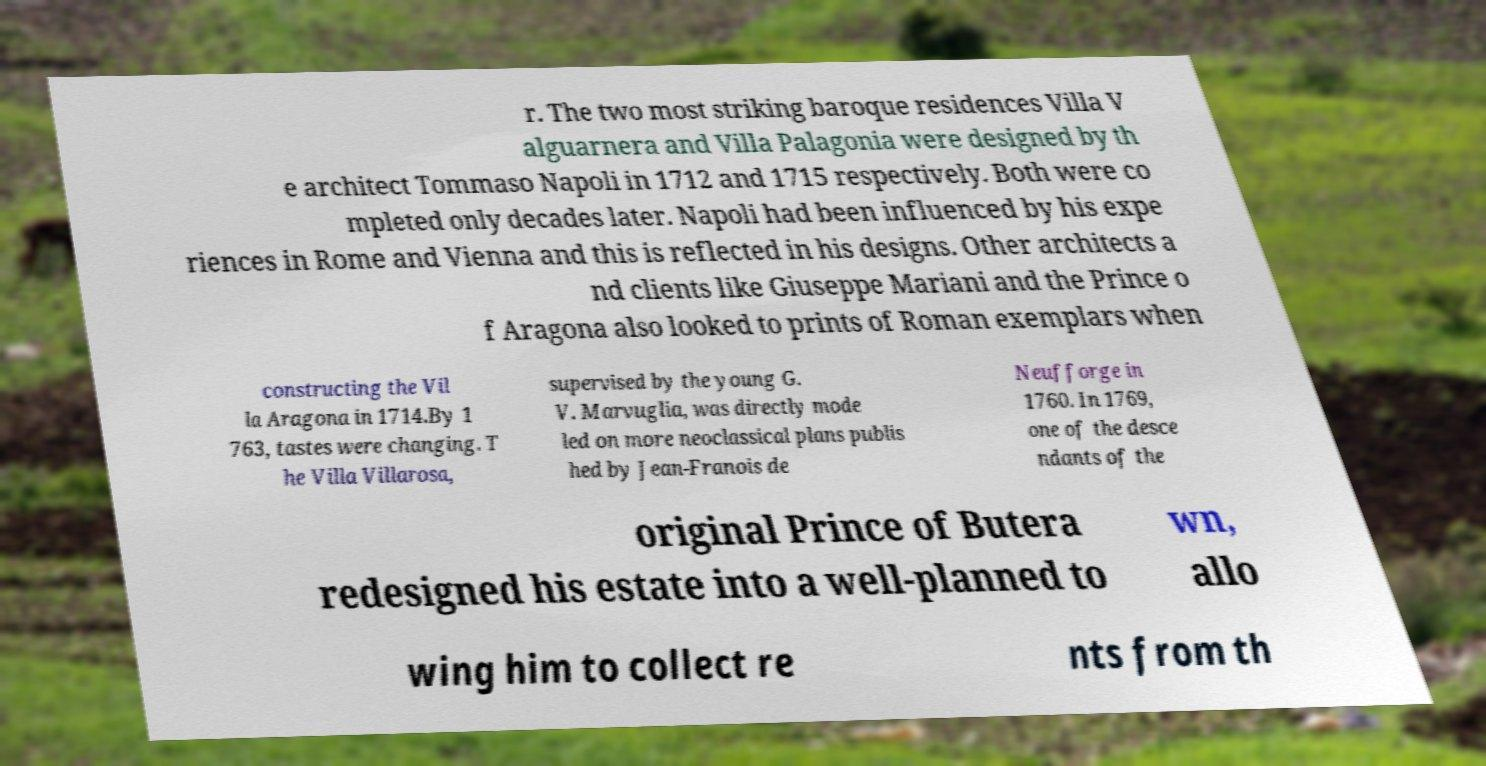For documentation purposes, I need the text within this image transcribed. Could you provide that? r. The two most striking baroque residences Villa V alguarnera and Villa Palagonia were designed by th e architect Tommaso Napoli in 1712 and 1715 respectively. Both were co mpleted only decades later. Napoli had been influenced by his expe riences in Rome and Vienna and this is reflected in his designs. Other architects a nd clients like Giuseppe Mariani and the Prince o f Aragona also looked to prints of Roman exemplars when constructing the Vil la Aragona in 1714.By 1 763, tastes were changing. T he Villa Villarosa, supervised by the young G. V. Marvuglia, was directly mode led on more neoclassical plans publis hed by Jean-Franois de Neufforge in 1760. In 1769, one of the desce ndants of the original Prince of Butera redesigned his estate into a well-planned to wn, allo wing him to collect re nts from th 